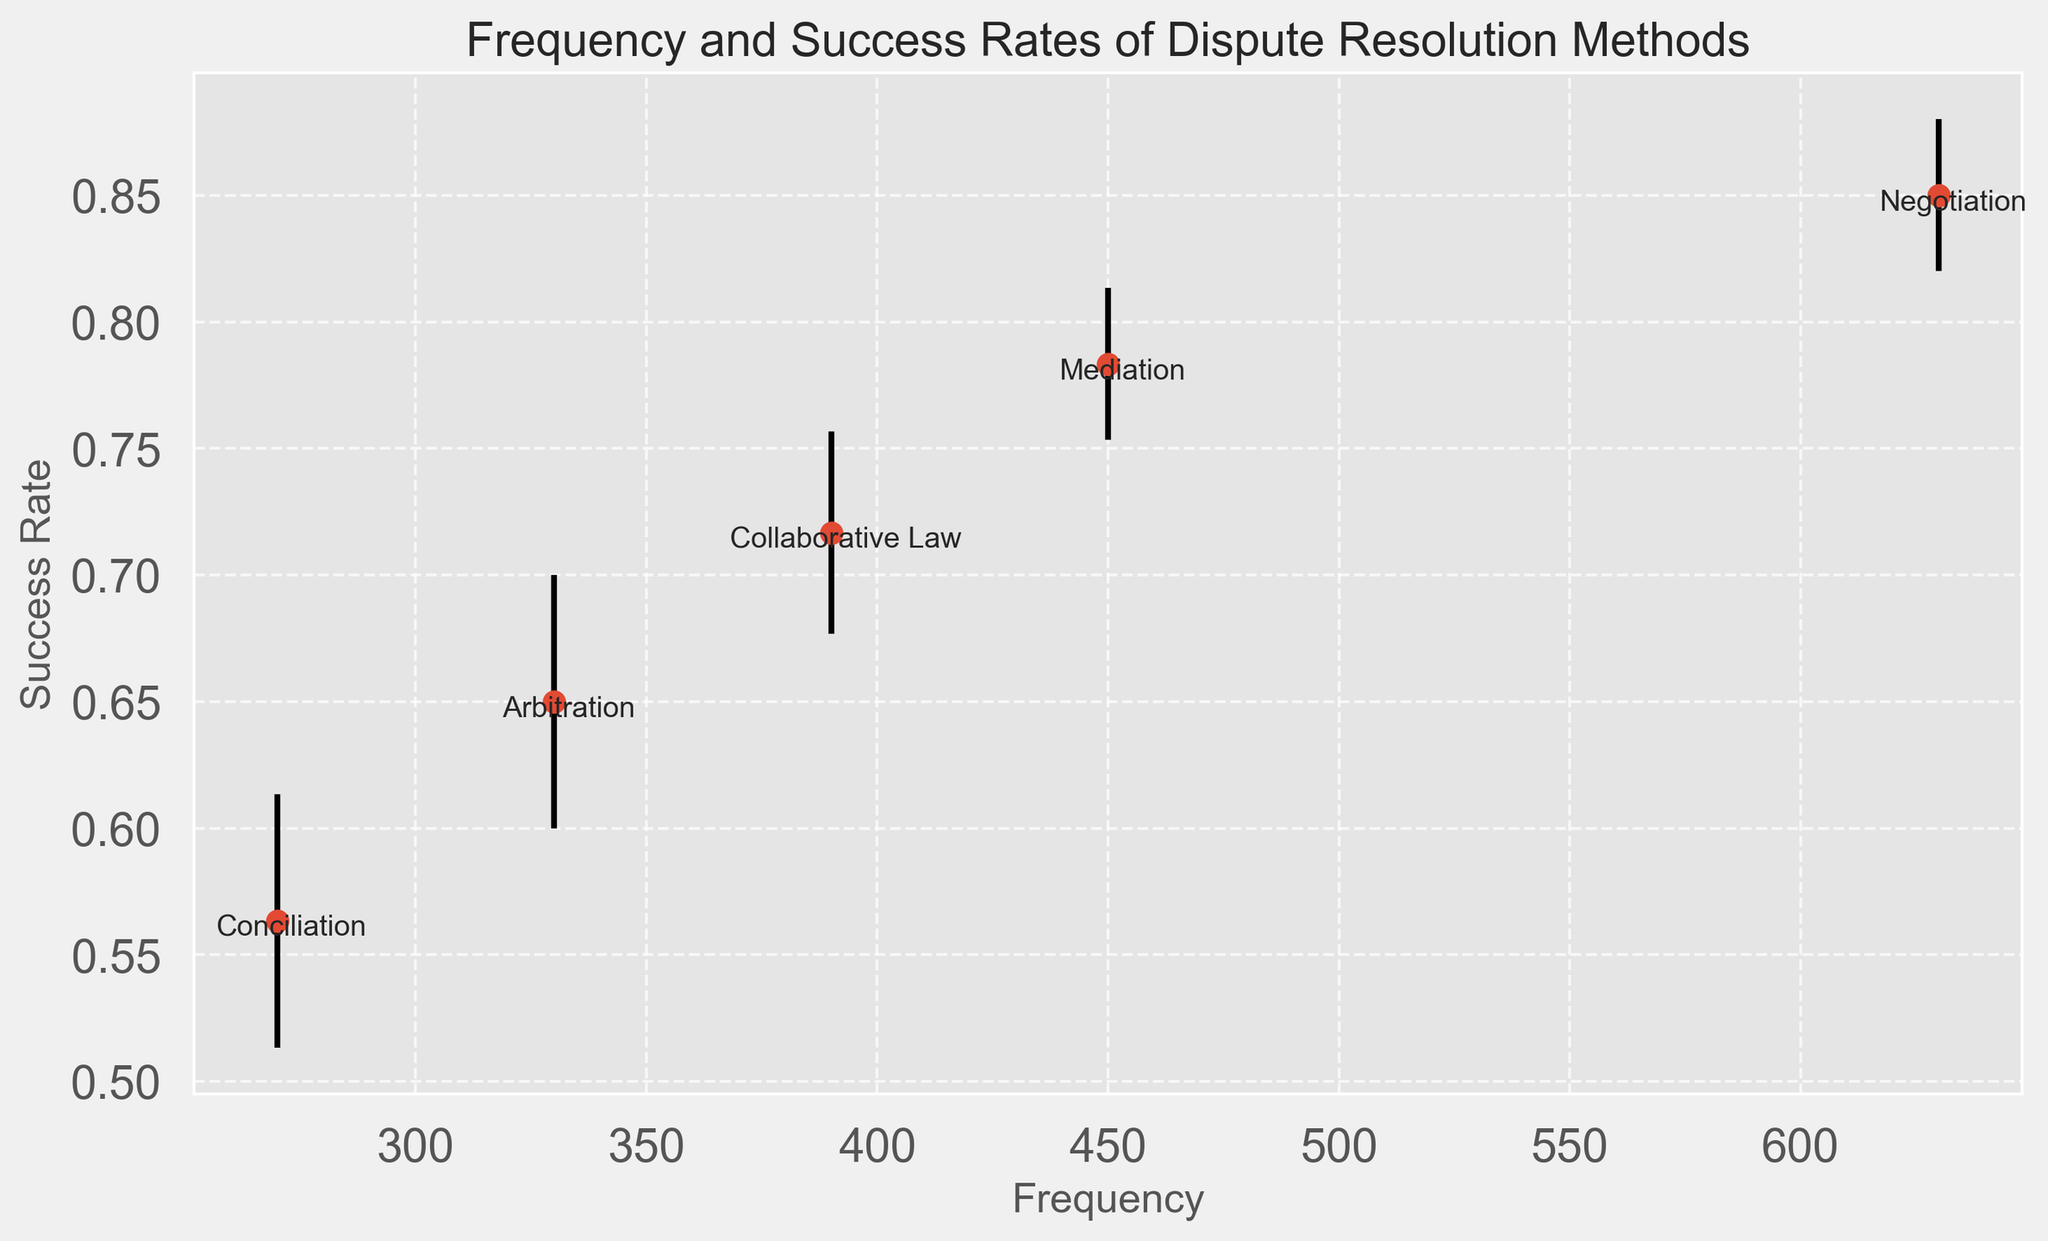What method has the highest frequency? To find the method with the highest frequency, look for the data point that is farthest right on the x-axis.
Answer: Negotiation What is the range of success rates for Mediation? The success rates for Mediation range between the error bars for the Mediation points. The lower bound is 0.75 and the upper bound is 0.83.
Answer: 0.75 to 0.83 Which method has the lowest average success rate? To determine the method with the lowest success rate, look for the data point with the lowest position on the y-axis.
Answer: Conciliation What is the difference in frequency between Mediation and Arbitration? Mediation has a frequency of 450 (sum of all Mediation frequencies) and Arbitration has a frequency of 330 (sum of all Arbitration frequencies). The difference is 450 - 330.
Answer: 120 Which method shows the widest confidence interval for success rates? The width of the confidence interval is given by the difference between the upper and lower bounds of the error bars. Calculate the differences for each method and compare.
Answer: Collaborative Law Compare the success rates of Arbitration and Conciliation. Which one is higher and by how much? Arbitration has higher success rates (0.65) compared to Conciliation (0.56). The difference is 0.65 - 0.56.
Answer: Arbitration by 0.09 What is the average success rate of all methods combined? Find the success rates of each method (averaged) and then take the overall mean: (0.78 + 0.65 + 0.72 + 0.55 + 0.85 + 0.80 + 0.64 + 0.70 + 0.58 + 0.86 + 0.77 + 0.66 + 0.73 + 0.56 + 0.84) / 14.
Answer: 0.72 Does any method have an overlapping confidence interval with Mediation? We need to check if any of the confidence intervals from other methods overlap with Mediation's range of 0.75 to 0.83.
Answer: Yes, Collaborative Law 